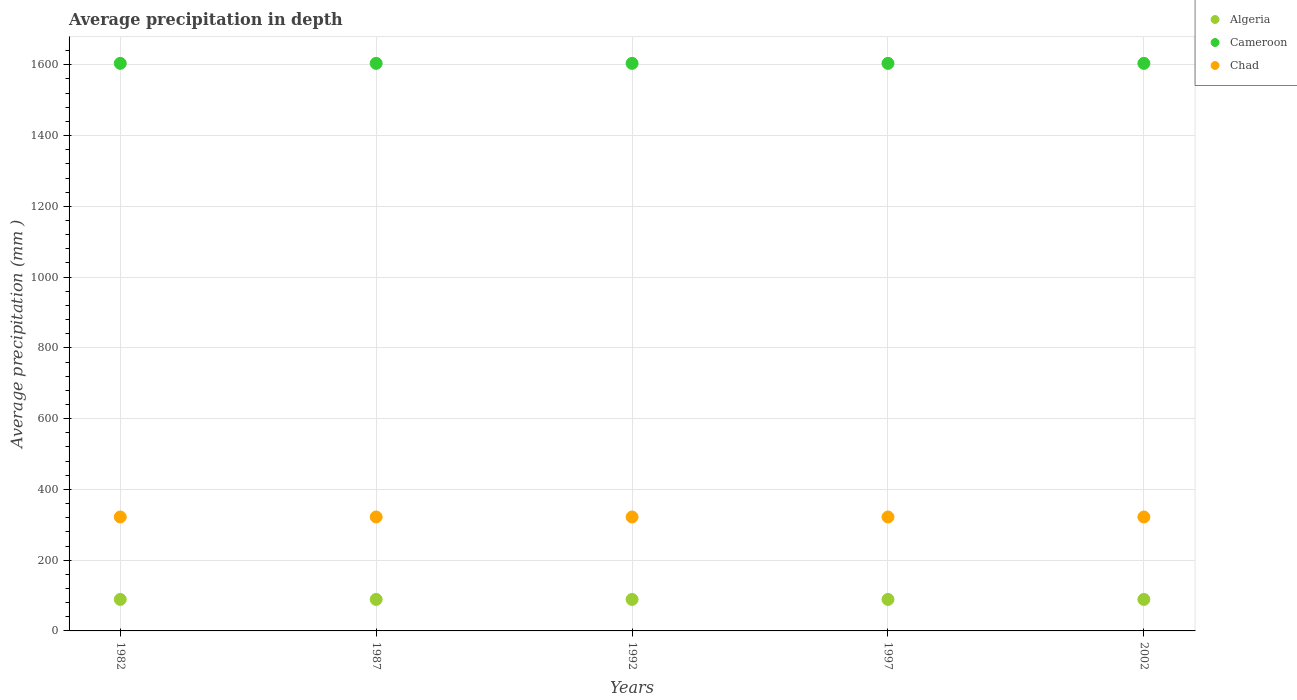How many different coloured dotlines are there?
Give a very brief answer. 3. What is the average precipitation in Cameroon in 2002?
Offer a terse response. 1604. Across all years, what is the maximum average precipitation in Algeria?
Make the answer very short. 89. Across all years, what is the minimum average precipitation in Cameroon?
Make the answer very short. 1604. In which year was the average precipitation in Algeria maximum?
Offer a very short reply. 1982. In which year was the average precipitation in Chad minimum?
Keep it short and to the point. 1982. What is the total average precipitation in Algeria in the graph?
Give a very brief answer. 445. What is the difference between the average precipitation in Cameroon in 1987 and that in 1997?
Provide a succinct answer. 0. What is the difference between the average precipitation in Chad in 1992 and the average precipitation in Algeria in 1982?
Make the answer very short. 233. What is the average average precipitation in Chad per year?
Offer a terse response. 322. In the year 1992, what is the difference between the average precipitation in Cameroon and average precipitation in Chad?
Make the answer very short. 1282. In how many years, is the average precipitation in Chad greater than 1160 mm?
Your answer should be very brief. 0. What is the ratio of the average precipitation in Algeria in 1997 to that in 2002?
Your answer should be very brief. 1. Is the average precipitation in Cameroon in 1987 less than that in 2002?
Ensure brevity in your answer.  No. Is the difference between the average precipitation in Cameroon in 1982 and 1997 greater than the difference between the average precipitation in Chad in 1982 and 1997?
Provide a succinct answer. No. What is the difference between the highest and the lowest average precipitation in Chad?
Provide a short and direct response. 0. Is it the case that in every year, the sum of the average precipitation in Chad and average precipitation in Cameroon  is greater than the average precipitation in Algeria?
Offer a very short reply. Yes. Does the average precipitation in Cameroon monotonically increase over the years?
Provide a succinct answer. No. What is the difference between two consecutive major ticks on the Y-axis?
Offer a very short reply. 200. Are the values on the major ticks of Y-axis written in scientific E-notation?
Make the answer very short. No. Does the graph contain any zero values?
Provide a succinct answer. No. Where does the legend appear in the graph?
Keep it short and to the point. Top right. How many legend labels are there?
Your answer should be compact. 3. How are the legend labels stacked?
Your answer should be compact. Vertical. What is the title of the graph?
Make the answer very short. Average precipitation in depth. What is the label or title of the Y-axis?
Make the answer very short. Average precipitation (mm ). What is the Average precipitation (mm ) in Algeria in 1982?
Ensure brevity in your answer.  89. What is the Average precipitation (mm ) of Cameroon in 1982?
Ensure brevity in your answer.  1604. What is the Average precipitation (mm ) in Chad in 1982?
Provide a short and direct response. 322. What is the Average precipitation (mm ) in Algeria in 1987?
Your answer should be compact. 89. What is the Average precipitation (mm ) of Cameroon in 1987?
Your answer should be very brief. 1604. What is the Average precipitation (mm ) of Chad in 1987?
Provide a succinct answer. 322. What is the Average precipitation (mm ) in Algeria in 1992?
Offer a very short reply. 89. What is the Average precipitation (mm ) in Cameroon in 1992?
Offer a very short reply. 1604. What is the Average precipitation (mm ) in Chad in 1992?
Your answer should be very brief. 322. What is the Average precipitation (mm ) in Algeria in 1997?
Ensure brevity in your answer.  89. What is the Average precipitation (mm ) of Cameroon in 1997?
Your answer should be compact. 1604. What is the Average precipitation (mm ) in Chad in 1997?
Provide a succinct answer. 322. What is the Average precipitation (mm ) of Algeria in 2002?
Keep it short and to the point. 89. What is the Average precipitation (mm ) in Cameroon in 2002?
Offer a terse response. 1604. What is the Average precipitation (mm ) of Chad in 2002?
Offer a very short reply. 322. Across all years, what is the maximum Average precipitation (mm ) of Algeria?
Your answer should be very brief. 89. Across all years, what is the maximum Average precipitation (mm ) in Cameroon?
Ensure brevity in your answer.  1604. Across all years, what is the maximum Average precipitation (mm ) in Chad?
Your response must be concise. 322. Across all years, what is the minimum Average precipitation (mm ) in Algeria?
Your answer should be very brief. 89. Across all years, what is the minimum Average precipitation (mm ) of Cameroon?
Keep it short and to the point. 1604. Across all years, what is the minimum Average precipitation (mm ) in Chad?
Your response must be concise. 322. What is the total Average precipitation (mm ) of Algeria in the graph?
Your response must be concise. 445. What is the total Average precipitation (mm ) of Cameroon in the graph?
Your answer should be very brief. 8020. What is the total Average precipitation (mm ) in Chad in the graph?
Give a very brief answer. 1610. What is the difference between the Average precipitation (mm ) of Algeria in 1982 and that in 1987?
Ensure brevity in your answer.  0. What is the difference between the Average precipitation (mm ) in Chad in 1982 and that in 1987?
Your response must be concise. 0. What is the difference between the Average precipitation (mm ) in Algeria in 1982 and that in 1992?
Give a very brief answer. 0. What is the difference between the Average precipitation (mm ) in Chad in 1982 and that in 1992?
Keep it short and to the point. 0. What is the difference between the Average precipitation (mm ) of Cameroon in 1982 and that in 2002?
Make the answer very short. 0. What is the difference between the Average precipitation (mm ) in Chad in 1987 and that in 1992?
Ensure brevity in your answer.  0. What is the difference between the Average precipitation (mm ) of Algeria in 1987 and that in 1997?
Provide a succinct answer. 0. What is the difference between the Average precipitation (mm ) of Algeria in 1987 and that in 2002?
Offer a very short reply. 0. What is the difference between the Average precipitation (mm ) in Cameroon in 1987 and that in 2002?
Ensure brevity in your answer.  0. What is the difference between the Average precipitation (mm ) of Chad in 1987 and that in 2002?
Make the answer very short. 0. What is the difference between the Average precipitation (mm ) in Cameroon in 1992 and that in 1997?
Provide a succinct answer. 0. What is the difference between the Average precipitation (mm ) of Algeria in 1992 and that in 2002?
Ensure brevity in your answer.  0. What is the difference between the Average precipitation (mm ) in Chad in 1992 and that in 2002?
Offer a terse response. 0. What is the difference between the Average precipitation (mm ) of Cameroon in 1997 and that in 2002?
Provide a succinct answer. 0. What is the difference between the Average precipitation (mm ) in Chad in 1997 and that in 2002?
Offer a very short reply. 0. What is the difference between the Average precipitation (mm ) of Algeria in 1982 and the Average precipitation (mm ) of Cameroon in 1987?
Offer a very short reply. -1515. What is the difference between the Average precipitation (mm ) in Algeria in 1982 and the Average precipitation (mm ) in Chad in 1987?
Your answer should be very brief. -233. What is the difference between the Average precipitation (mm ) in Cameroon in 1982 and the Average precipitation (mm ) in Chad in 1987?
Ensure brevity in your answer.  1282. What is the difference between the Average precipitation (mm ) of Algeria in 1982 and the Average precipitation (mm ) of Cameroon in 1992?
Give a very brief answer. -1515. What is the difference between the Average precipitation (mm ) of Algeria in 1982 and the Average precipitation (mm ) of Chad in 1992?
Make the answer very short. -233. What is the difference between the Average precipitation (mm ) of Cameroon in 1982 and the Average precipitation (mm ) of Chad in 1992?
Your response must be concise. 1282. What is the difference between the Average precipitation (mm ) of Algeria in 1982 and the Average precipitation (mm ) of Cameroon in 1997?
Provide a short and direct response. -1515. What is the difference between the Average precipitation (mm ) in Algeria in 1982 and the Average precipitation (mm ) in Chad in 1997?
Give a very brief answer. -233. What is the difference between the Average precipitation (mm ) in Cameroon in 1982 and the Average precipitation (mm ) in Chad in 1997?
Ensure brevity in your answer.  1282. What is the difference between the Average precipitation (mm ) of Algeria in 1982 and the Average precipitation (mm ) of Cameroon in 2002?
Keep it short and to the point. -1515. What is the difference between the Average precipitation (mm ) in Algeria in 1982 and the Average precipitation (mm ) in Chad in 2002?
Offer a very short reply. -233. What is the difference between the Average precipitation (mm ) of Cameroon in 1982 and the Average precipitation (mm ) of Chad in 2002?
Provide a succinct answer. 1282. What is the difference between the Average precipitation (mm ) in Algeria in 1987 and the Average precipitation (mm ) in Cameroon in 1992?
Offer a very short reply. -1515. What is the difference between the Average precipitation (mm ) of Algeria in 1987 and the Average precipitation (mm ) of Chad in 1992?
Offer a terse response. -233. What is the difference between the Average precipitation (mm ) in Cameroon in 1987 and the Average precipitation (mm ) in Chad in 1992?
Ensure brevity in your answer.  1282. What is the difference between the Average precipitation (mm ) in Algeria in 1987 and the Average precipitation (mm ) in Cameroon in 1997?
Offer a very short reply. -1515. What is the difference between the Average precipitation (mm ) in Algeria in 1987 and the Average precipitation (mm ) in Chad in 1997?
Ensure brevity in your answer.  -233. What is the difference between the Average precipitation (mm ) in Cameroon in 1987 and the Average precipitation (mm ) in Chad in 1997?
Offer a very short reply. 1282. What is the difference between the Average precipitation (mm ) of Algeria in 1987 and the Average precipitation (mm ) of Cameroon in 2002?
Give a very brief answer. -1515. What is the difference between the Average precipitation (mm ) in Algeria in 1987 and the Average precipitation (mm ) in Chad in 2002?
Make the answer very short. -233. What is the difference between the Average precipitation (mm ) of Cameroon in 1987 and the Average precipitation (mm ) of Chad in 2002?
Provide a short and direct response. 1282. What is the difference between the Average precipitation (mm ) of Algeria in 1992 and the Average precipitation (mm ) of Cameroon in 1997?
Your answer should be compact. -1515. What is the difference between the Average precipitation (mm ) of Algeria in 1992 and the Average precipitation (mm ) of Chad in 1997?
Make the answer very short. -233. What is the difference between the Average precipitation (mm ) in Cameroon in 1992 and the Average precipitation (mm ) in Chad in 1997?
Keep it short and to the point. 1282. What is the difference between the Average precipitation (mm ) of Algeria in 1992 and the Average precipitation (mm ) of Cameroon in 2002?
Your answer should be compact. -1515. What is the difference between the Average precipitation (mm ) of Algeria in 1992 and the Average precipitation (mm ) of Chad in 2002?
Keep it short and to the point. -233. What is the difference between the Average precipitation (mm ) of Cameroon in 1992 and the Average precipitation (mm ) of Chad in 2002?
Your response must be concise. 1282. What is the difference between the Average precipitation (mm ) in Algeria in 1997 and the Average precipitation (mm ) in Cameroon in 2002?
Make the answer very short. -1515. What is the difference between the Average precipitation (mm ) of Algeria in 1997 and the Average precipitation (mm ) of Chad in 2002?
Your answer should be compact. -233. What is the difference between the Average precipitation (mm ) in Cameroon in 1997 and the Average precipitation (mm ) in Chad in 2002?
Your response must be concise. 1282. What is the average Average precipitation (mm ) of Algeria per year?
Provide a short and direct response. 89. What is the average Average precipitation (mm ) of Cameroon per year?
Give a very brief answer. 1604. What is the average Average precipitation (mm ) in Chad per year?
Ensure brevity in your answer.  322. In the year 1982, what is the difference between the Average precipitation (mm ) of Algeria and Average precipitation (mm ) of Cameroon?
Offer a very short reply. -1515. In the year 1982, what is the difference between the Average precipitation (mm ) of Algeria and Average precipitation (mm ) of Chad?
Offer a very short reply. -233. In the year 1982, what is the difference between the Average precipitation (mm ) of Cameroon and Average precipitation (mm ) of Chad?
Make the answer very short. 1282. In the year 1987, what is the difference between the Average precipitation (mm ) of Algeria and Average precipitation (mm ) of Cameroon?
Provide a succinct answer. -1515. In the year 1987, what is the difference between the Average precipitation (mm ) of Algeria and Average precipitation (mm ) of Chad?
Make the answer very short. -233. In the year 1987, what is the difference between the Average precipitation (mm ) in Cameroon and Average precipitation (mm ) in Chad?
Make the answer very short. 1282. In the year 1992, what is the difference between the Average precipitation (mm ) in Algeria and Average precipitation (mm ) in Cameroon?
Ensure brevity in your answer.  -1515. In the year 1992, what is the difference between the Average precipitation (mm ) in Algeria and Average precipitation (mm ) in Chad?
Your answer should be compact. -233. In the year 1992, what is the difference between the Average precipitation (mm ) of Cameroon and Average precipitation (mm ) of Chad?
Make the answer very short. 1282. In the year 1997, what is the difference between the Average precipitation (mm ) in Algeria and Average precipitation (mm ) in Cameroon?
Provide a succinct answer. -1515. In the year 1997, what is the difference between the Average precipitation (mm ) of Algeria and Average precipitation (mm ) of Chad?
Ensure brevity in your answer.  -233. In the year 1997, what is the difference between the Average precipitation (mm ) of Cameroon and Average precipitation (mm ) of Chad?
Offer a very short reply. 1282. In the year 2002, what is the difference between the Average precipitation (mm ) of Algeria and Average precipitation (mm ) of Cameroon?
Offer a terse response. -1515. In the year 2002, what is the difference between the Average precipitation (mm ) of Algeria and Average precipitation (mm ) of Chad?
Your answer should be very brief. -233. In the year 2002, what is the difference between the Average precipitation (mm ) of Cameroon and Average precipitation (mm ) of Chad?
Your response must be concise. 1282. What is the ratio of the Average precipitation (mm ) in Cameroon in 1982 to that in 1987?
Your answer should be very brief. 1. What is the ratio of the Average precipitation (mm ) of Chad in 1982 to that in 1987?
Provide a succinct answer. 1. What is the ratio of the Average precipitation (mm ) of Chad in 1982 to that in 1992?
Your answer should be very brief. 1. What is the ratio of the Average precipitation (mm ) in Algeria in 1982 to that in 1997?
Offer a very short reply. 1. What is the ratio of the Average precipitation (mm ) of Cameroon in 1982 to that in 1997?
Make the answer very short. 1. What is the ratio of the Average precipitation (mm ) of Algeria in 1982 to that in 2002?
Provide a short and direct response. 1. What is the ratio of the Average precipitation (mm ) in Cameroon in 1987 to that in 2002?
Offer a terse response. 1. What is the ratio of the Average precipitation (mm ) in Algeria in 1992 to that in 1997?
Ensure brevity in your answer.  1. What is the ratio of the Average precipitation (mm ) in Chad in 1992 to that in 1997?
Your response must be concise. 1. What is the ratio of the Average precipitation (mm ) in Cameroon in 1992 to that in 2002?
Offer a terse response. 1. What is the ratio of the Average precipitation (mm ) in Cameroon in 1997 to that in 2002?
Provide a short and direct response. 1. What is the difference between the highest and the second highest Average precipitation (mm ) in Algeria?
Your answer should be compact. 0. What is the difference between the highest and the second highest Average precipitation (mm ) of Cameroon?
Ensure brevity in your answer.  0. What is the difference between the highest and the second highest Average precipitation (mm ) of Chad?
Your answer should be compact. 0. What is the difference between the highest and the lowest Average precipitation (mm ) in Algeria?
Offer a terse response. 0. 